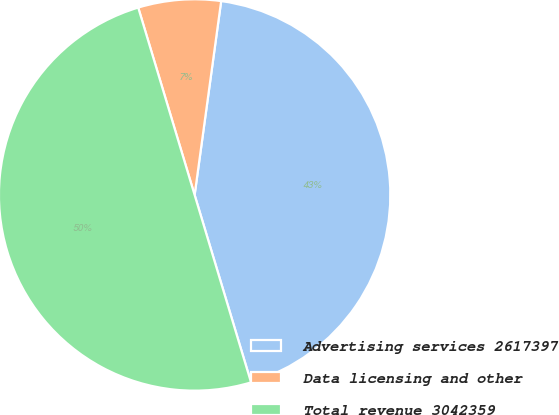<chart> <loc_0><loc_0><loc_500><loc_500><pie_chart><fcel>Advertising services 2617397<fcel>Data licensing and other<fcel>Total revenue 3042359<nl><fcel>43.18%<fcel>6.82%<fcel>50.0%<nl></chart> 